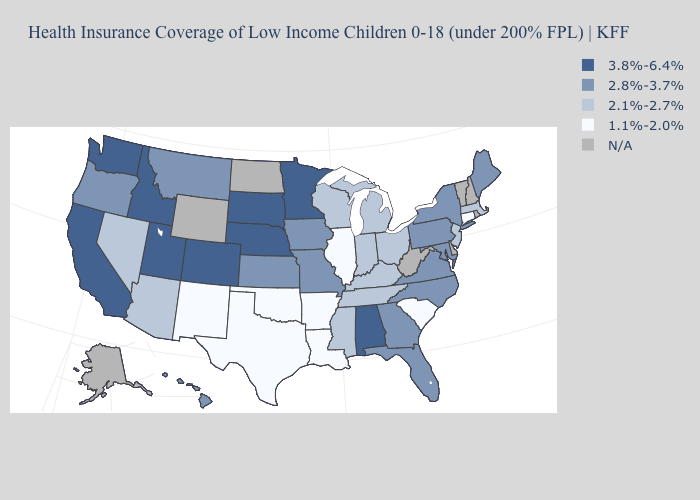Name the states that have a value in the range 2.1%-2.7%?
Answer briefly. Arizona, Indiana, Kentucky, Massachusetts, Michigan, Mississippi, Nevada, New Jersey, Ohio, Tennessee, Wisconsin. Name the states that have a value in the range 2.1%-2.7%?
Answer briefly. Arizona, Indiana, Kentucky, Massachusetts, Michigan, Mississippi, Nevada, New Jersey, Ohio, Tennessee, Wisconsin. Name the states that have a value in the range 3.8%-6.4%?
Write a very short answer. Alabama, California, Colorado, Idaho, Minnesota, Nebraska, South Dakota, Utah, Washington. Name the states that have a value in the range 1.1%-2.0%?
Answer briefly. Arkansas, Connecticut, Illinois, Louisiana, New Mexico, Oklahoma, South Carolina, Texas. Does the first symbol in the legend represent the smallest category?
Be succinct. No. Name the states that have a value in the range 2.1%-2.7%?
Write a very short answer. Arizona, Indiana, Kentucky, Massachusetts, Michigan, Mississippi, Nevada, New Jersey, Ohio, Tennessee, Wisconsin. Does Alabama have the highest value in the USA?
Concise answer only. Yes. Which states have the lowest value in the USA?
Short answer required. Arkansas, Connecticut, Illinois, Louisiana, New Mexico, Oklahoma, South Carolina, Texas. Name the states that have a value in the range 3.8%-6.4%?
Concise answer only. Alabama, California, Colorado, Idaho, Minnesota, Nebraska, South Dakota, Utah, Washington. Name the states that have a value in the range 2.1%-2.7%?
Keep it brief. Arizona, Indiana, Kentucky, Massachusetts, Michigan, Mississippi, Nevada, New Jersey, Ohio, Tennessee, Wisconsin. What is the value of Massachusetts?
Short answer required. 2.1%-2.7%. 